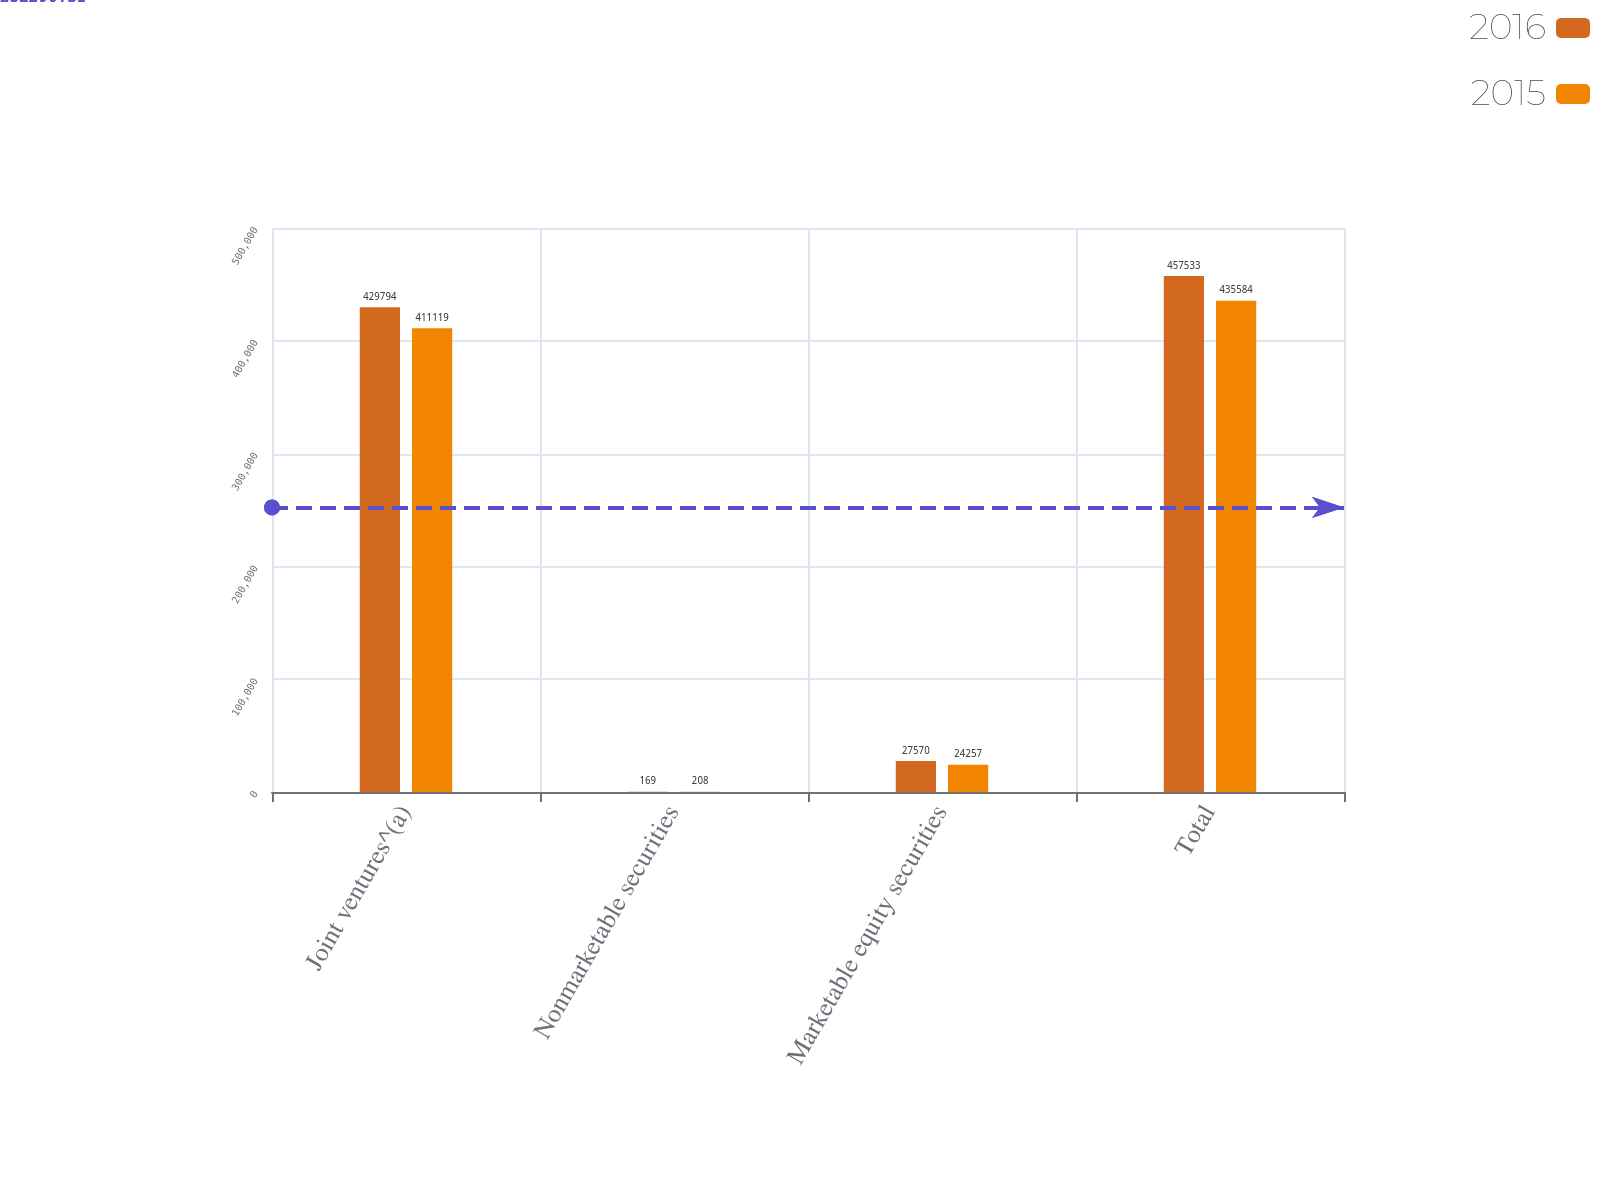<chart> <loc_0><loc_0><loc_500><loc_500><stacked_bar_chart><ecel><fcel>Joint ventures^(a)<fcel>Nonmarketable securities<fcel>Marketable equity securities<fcel>Total<nl><fcel>2016<fcel>429794<fcel>169<fcel>27570<fcel>457533<nl><fcel>2015<fcel>411119<fcel>208<fcel>24257<fcel>435584<nl></chart> 